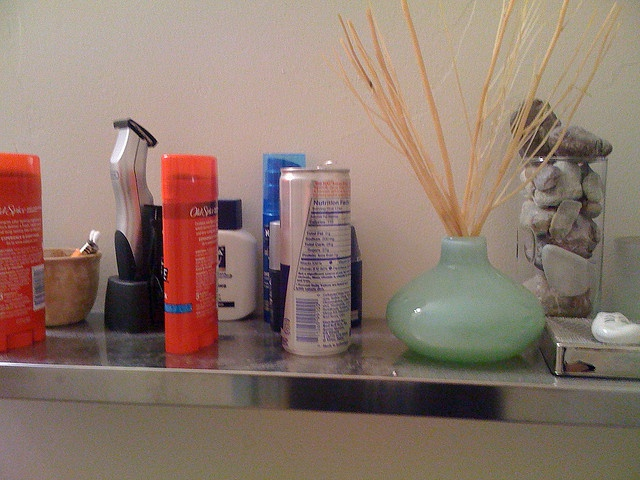Describe the objects in this image and their specific colors. I can see vase in darkgray and gray tones, cup in darkgray and gray tones, bottle in darkgray, gray, and black tones, bowl in darkgray, brown, and maroon tones, and cup in darkgray, brown, and maroon tones in this image. 